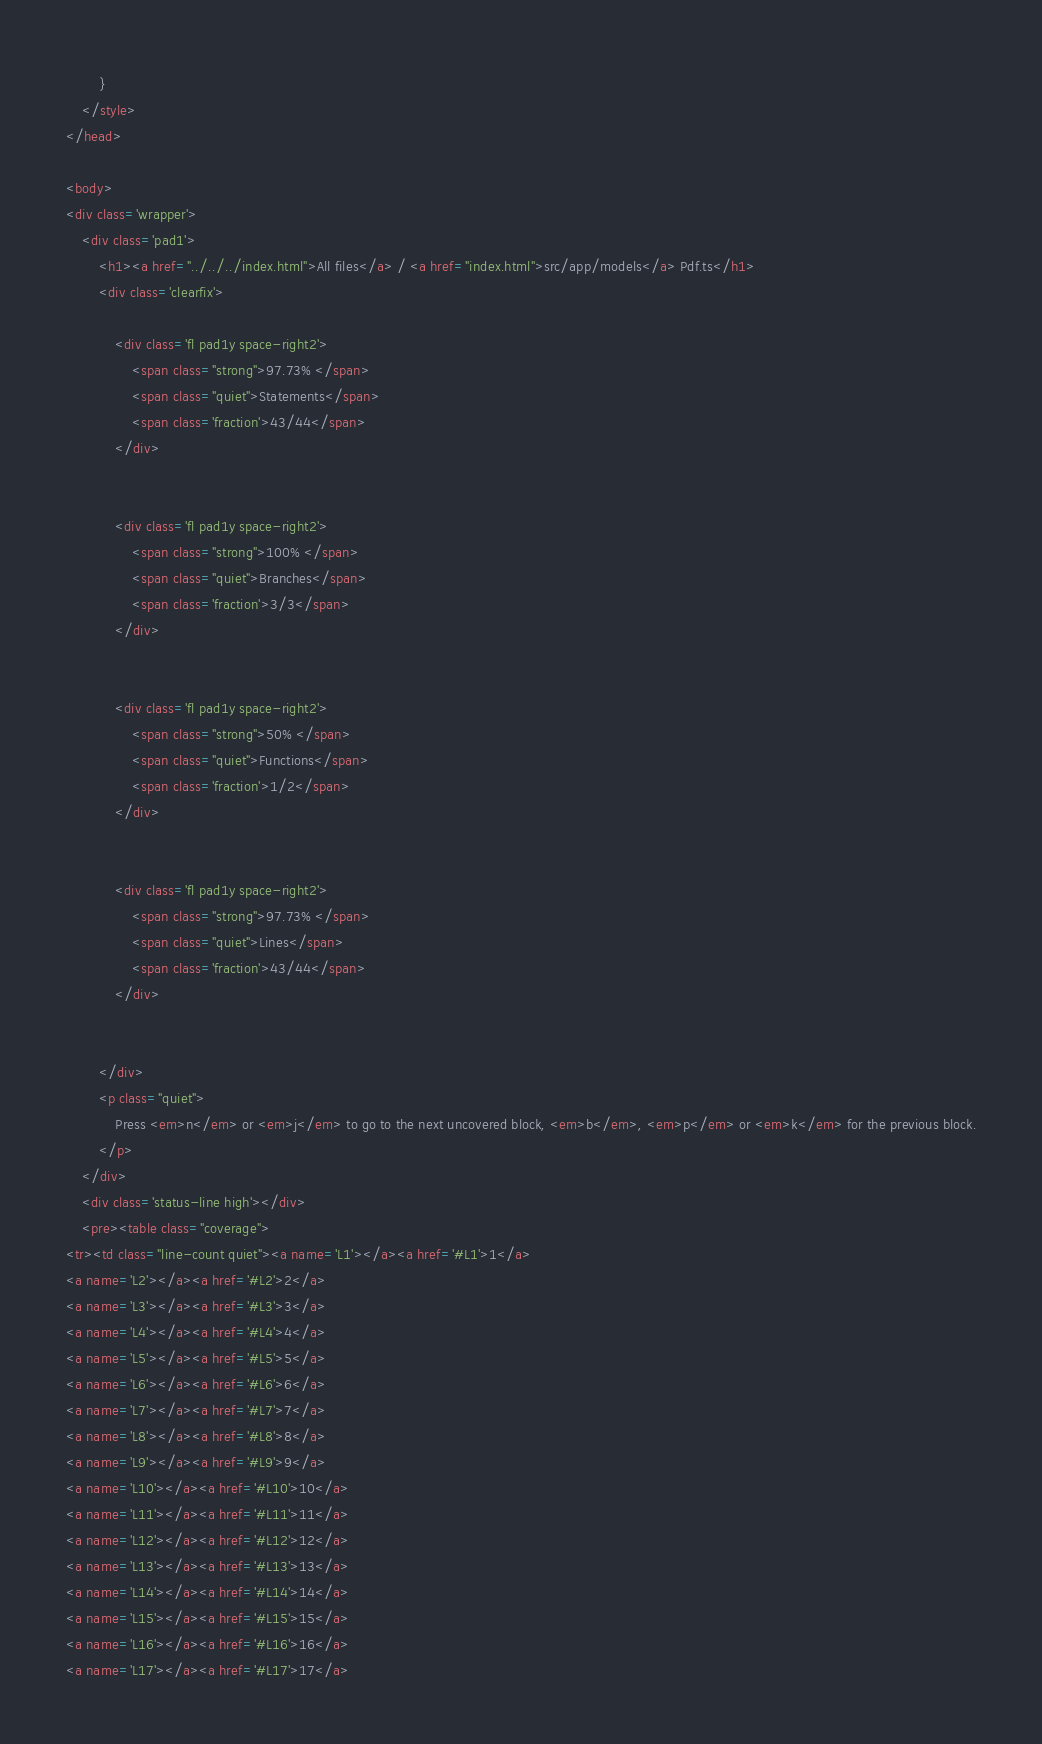<code> <loc_0><loc_0><loc_500><loc_500><_HTML_>        }
    </style>
</head>
    
<body>
<div class='wrapper'>
    <div class='pad1'>
        <h1><a href="../../../index.html">All files</a> / <a href="index.html">src/app/models</a> Pdf.ts</h1>
        <div class='clearfix'>
            
            <div class='fl pad1y space-right2'>
                <span class="strong">97.73% </span>
                <span class="quiet">Statements</span>
                <span class='fraction'>43/44</span>
            </div>
        
            
            <div class='fl pad1y space-right2'>
                <span class="strong">100% </span>
                <span class="quiet">Branches</span>
                <span class='fraction'>3/3</span>
            </div>
        
            
            <div class='fl pad1y space-right2'>
                <span class="strong">50% </span>
                <span class="quiet">Functions</span>
                <span class='fraction'>1/2</span>
            </div>
        
            
            <div class='fl pad1y space-right2'>
                <span class="strong">97.73% </span>
                <span class="quiet">Lines</span>
                <span class='fraction'>43/44</span>
            </div>
        
            
        </div>
        <p class="quiet">
            Press <em>n</em> or <em>j</em> to go to the next uncovered block, <em>b</em>, <em>p</em> or <em>k</em> for the previous block.
        </p>
    </div>
    <div class='status-line high'></div>
    <pre><table class="coverage">
<tr><td class="line-count quiet"><a name='L1'></a><a href='#L1'>1</a>
<a name='L2'></a><a href='#L2'>2</a>
<a name='L3'></a><a href='#L3'>3</a>
<a name='L4'></a><a href='#L4'>4</a>
<a name='L5'></a><a href='#L5'>5</a>
<a name='L6'></a><a href='#L6'>6</a>
<a name='L7'></a><a href='#L7'>7</a>
<a name='L8'></a><a href='#L8'>8</a>
<a name='L9'></a><a href='#L9'>9</a>
<a name='L10'></a><a href='#L10'>10</a>
<a name='L11'></a><a href='#L11'>11</a>
<a name='L12'></a><a href='#L12'>12</a>
<a name='L13'></a><a href='#L13'>13</a>
<a name='L14'></a><a href='#L14'>14</a>
<a name='L15'></a><a href='#L15'>15</a>
<a name='L16'></a><a href='#L16'>16</a>
<a name='L17'></a><a href='#L17'>17</a></code> 